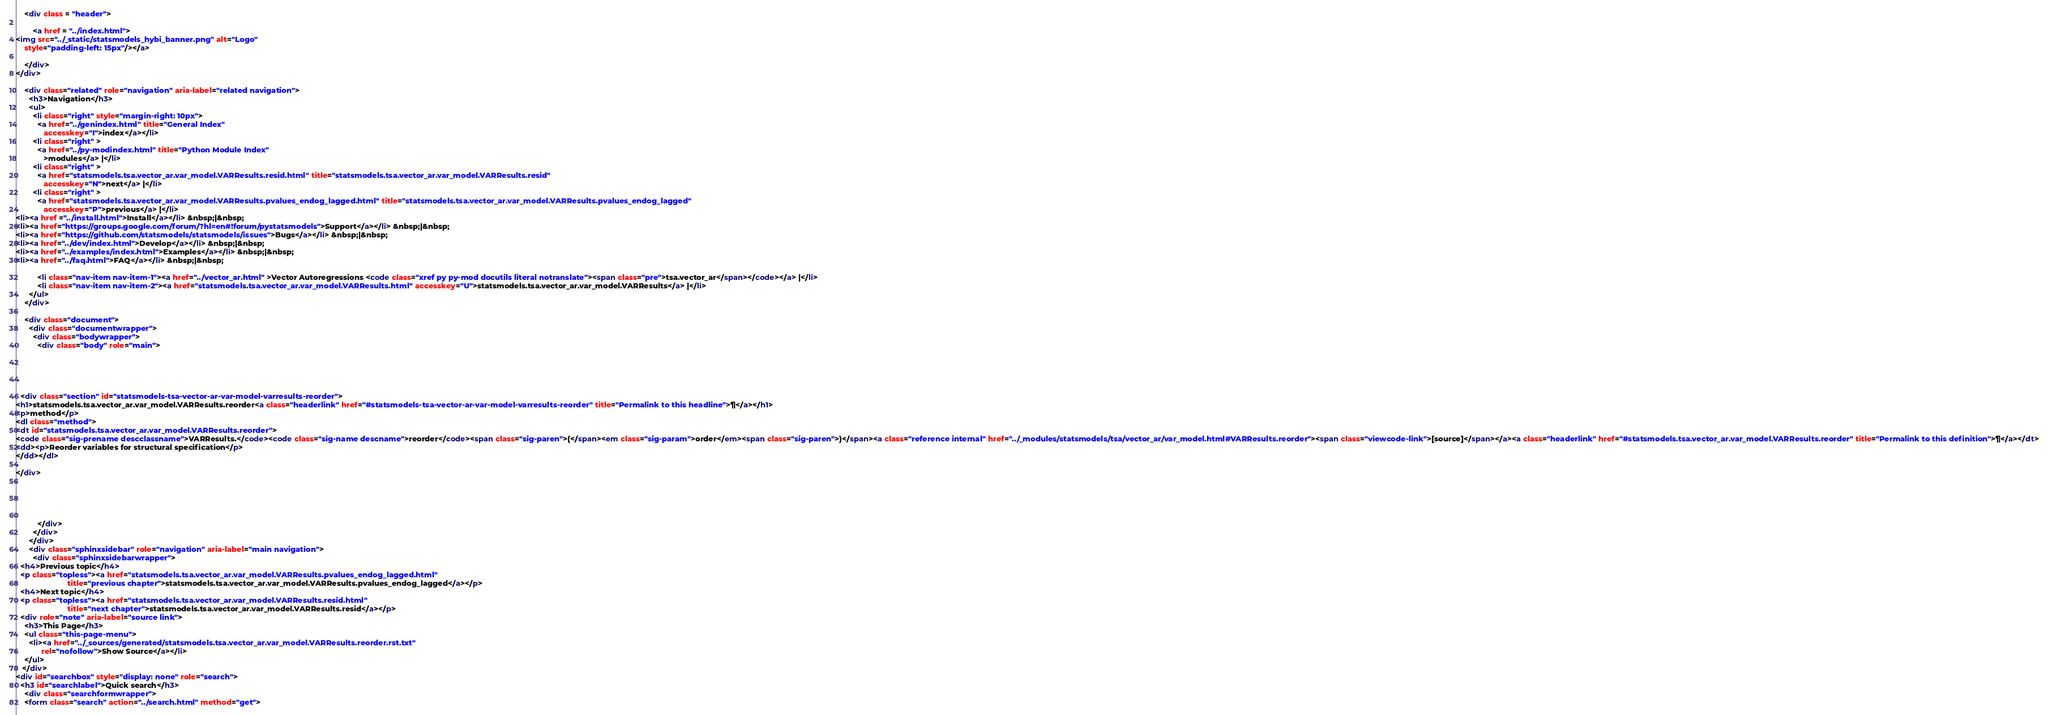<code> <loc_0><loc_0><loc_500><loc_500><_HTML_>    <div class = "header">
        
        <a href = "../index.html">
<img src="../_static/statsmodels_hybi_banner.png" alt="Logo"
    style="padding-left: 15px"/></a>
        
    </div>
</div>

    <div class="related" role="navigation" aria-label="related navigation">
      <h3>Navigation</h3>
      <ul>
        <li class="right" style="margin-right: 10px">
          <a href="../genindex.html" title="General Index"
             accesskey="I">index</a></li>
        <li class="right" >
          <a href="../py-modindex.html" title="Python Module Index"
             >modules</a> |</li>
        <li class="right" >
          <a href="statsmodels.tsa.vector_ar.var_model.VARResults.resid.html" title="statsmodels.tsa.vector_ar.var_model.VARResults.resid"
             accesskey="N">next</a> |</li>
        <li class="right" >
          <a href="statsmodels.tsa.vector_ar.var_model.VARResults.pvalues_endog_lagged.html" title="statsmodels.tsa.vector_ar.var_model.VARResults.pvalues_endog_lagged"
             accesskey="P">previous</a> |</li>
<li><a href ="../install.html">Install</a></li> &nbsp;|&nbsp;
<li><a href="https://groups.google.com/forum/?hl=en#!forum/pystatsmodels">Support</a></li> &nbsp;|&nbsp;
<li><a href="https://github.com/statsmodels/statsmodels/issues">Bugs</a></li> &nbsp;|&nbsp;
<li><a href="../dev/index.html">Develop</a></li> &nbsp;|&nbsp;
<li><a href="../examples/index.html">Examples</a></li> &nbsp;|&nbsp;
<li><a href="../faq.html">FAQ</a></li> &nbsp;|&nbsp;

          <li class="nav-item nav-item-1"><a href="../vector_ar.html" >Vector Autoregressions <code class="xref py py-mod docutils literal notranslate"><span class="pre">tsa.vector_ar</span></code></a> |</li>
          <li class="nav-item nav-item-2"><a href="statsmodels.tsa.vector_ar.var_model.VARResults.html" accesskey="U">statsmodels.tsa.vector_ar.var_model.VARResults</a> |</li> 
      </ul>
    </div>  

    <div class="document">
      <div class="documentwrapper">
        <div class="bodywrapper">
          <div class="body" role="main">
            




  <div class="section" id="statsmodels-tsa-vector-ar-var-model-varresults-reorder">
<h1>statsmodels.tsa.vector_ar.var_model.VARResults.reorder<a class="headerlink" href="#statsmodels-tsa-vector-ar-var-model-varresults-reorder" title="Permalink to this headline">¶</a></h1>
<p>method</p>
<dl class="method">
<dt id="statsmodels.tsa.vector_ar.var_model.VARResults.reorder">
<code class="sig-prename descclassname">VARResults.</code><code class="sig-name descname">reorder</code><span class="sig-paren">(</span><em class="sig-param">order</em><span class="sig-paren">)</span><a class="reference internal" href="../_modules/statsmodels/tsa/vector_ar/var_model.html#VARResults.reorder"><span class="viewcode-link">[source]</span></a><a class="headerlink" href="#statsmodels.tsa.vector_ar.var_model.VARResults.reorder" title="Permalink to this definition">¶</a></dt>
<dd><p>Reorder variables for structural specification</p>
</dd></dl>

</div>





          </div>
        </div>
      </div>
      <div class="sphinxsidebar" role="navigation" aria-label="main navigation">
        <div class="sphinxsidebarwrapper">
  <h4>Previous topic</h4>
  <p class="topless"><a href="statsmodels.tsa.vector_ar.var_model.VARResults.pvalues_endog_lagged.html"
                        title="previous chapter">statsmodels.tsa.vector_ar.var_model.VARResults.pvalues_endog_lagged</a></p>
  <h4>Next topic</h4>
  <p class="topless"><a href="statsmodels.tsa.vector_ar.var_model.VARResults.resid.html"
                        title="next chapter">statsmodels.tsa.vector_ar.var_model.VARResults.resid</a></p>
  <div role="note" aria-label="source link">
    <h3>This Page</h3>
    <ul class="this-page-menu">
      <li><a href="../_sources/generated/statsmodels.tsa.vector_ar.var_model.VARResults.reorder.rst.txt"
            rel="nofollow">Show Source</a></li>
    </ul>
   </div>
<div id="searchbox" style="display: none" role="search">
  <h3 id="searchlabel">Quick search</h3>
    <div class="searchformwrapper">
    <form class="search" action="../search.html" method="get"></code> 